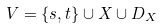<formula> <loc_0><loc_0><loc_500><loc_500>V = \{ s , t \} \cup X \cup D _ { X }</formula> 